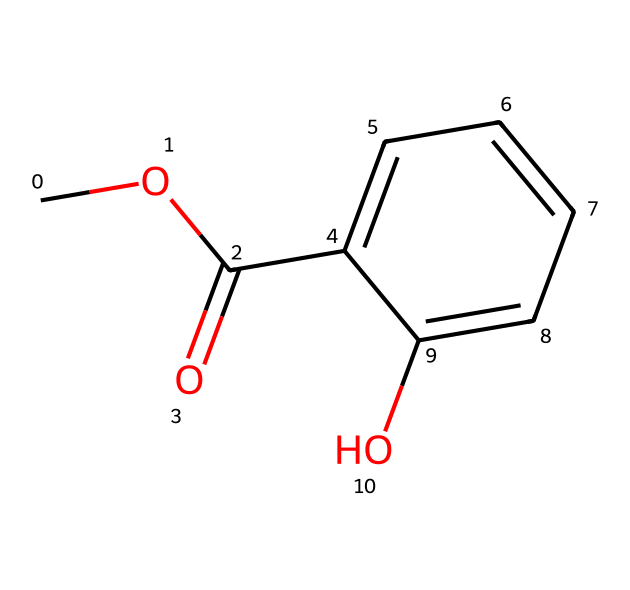What is the common name of this chemical? The SMILES representation indicates that the structure is methyl salicylate, which is a common ester often used in muscle rubs and pain relief creams.
Answer: methyl salicylate How many carbon atoms are present in the structure? By analyzing the SMILES, we can count the carbon atoms. The structure has 9 carbon atoms, which includes the carbon in the methoxy (-OCH3) group and the carbon atoms in the aromatic ring.
Answer: 9 What type of functional group is present in this chemical? The presence of the –COO- group in the structure indicates that this compound is an ester. Esters are characterized by their RCOOR’ structure.
Answer: ester How many hydrogen atoms are in methyl salicylate? To determine the number of hydrogen atoms, we can analyze the structure for each carbon and the associated hydrogen atoms. In this case, there are 10 hydrogen atoms in total.
Answer: 10 What role does the hydroxyl (-OH) group play in the structure? The hydroxyl (-OH) group, which is connected to the aromatic ring, can influence the polarity and solubility of the compound. It can also participate in hydrogen bonding, affecting the solubility in water and interactions with other compounds.
Answer: polarity and solubility Which part of the structure contributes to its aromatic properties? The chemical structure contains a benzene ring, which contributes to the aromatic properties of methyl salicylate. Aromatic compounds are characterized by their stable ring structure and delocalized electrons.
Answer: benzene ring Is this compound a solid or a liquid at room temperature? Methyl salicylate is known to be a liquid at room temperature, with a characteristic odor. Its low melting and boiling points confirm its liquid state.
Answer: liquid 